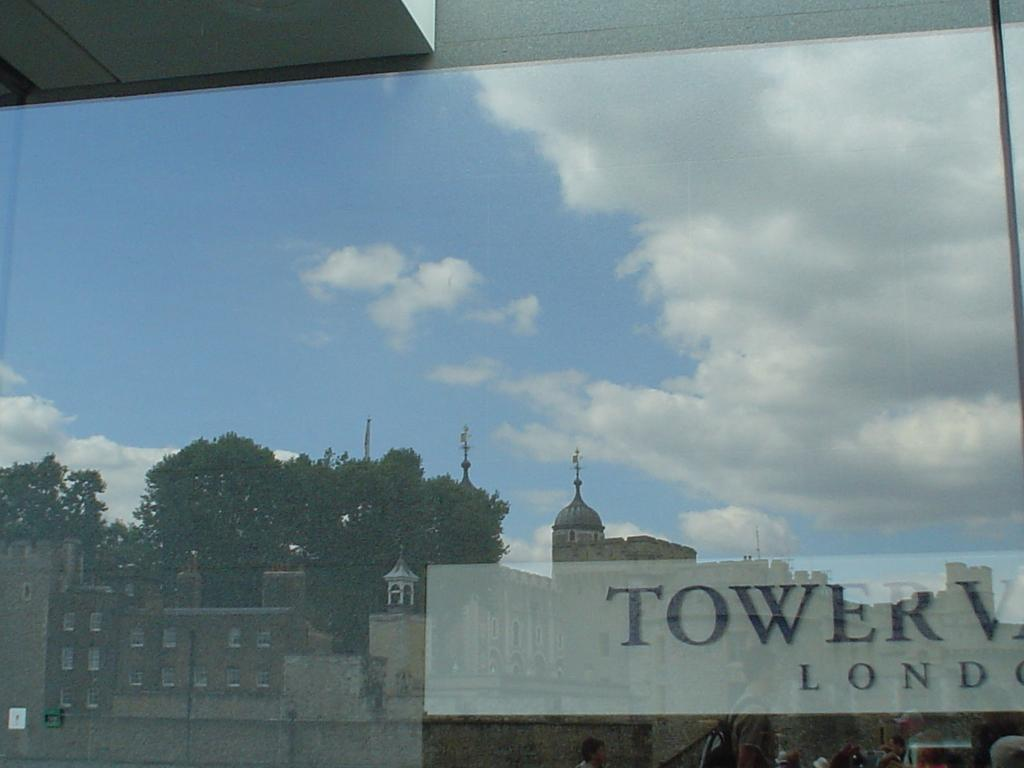<image>
Describe the image concisely. a Tower sign that is in front of buildings 